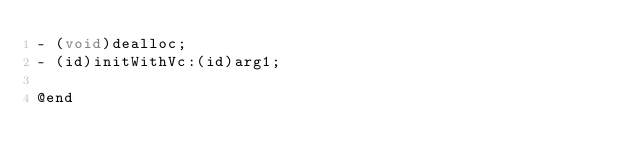Convert code to text. <code><loc_0><loc_0><loc_500><loc_500><_C_>- (void)dealloc;
- (id)initWithVc:(id)arg1;

@end

</code> 